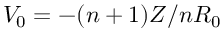<formula> <loc_0><loc_0><loc_500><loc_500>V _ { 0 } = - ( n + 1 ) Z / n R _ { 0 }</formula> 